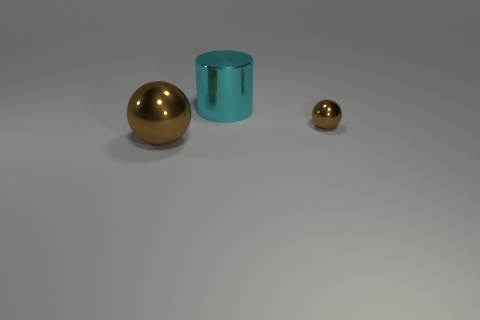Subtract all yellow cylinders. Subtract all yellow balls. How many cylinders are left? 1 Add 1 brown metallic objects. How many objects exist? 4 Subtract all cylinders. How many objects are left? 2 Add 1 metal cylinders. How many metal cylinders exist? 2 Subtract 0 purple spheres. How many objects are left? 3 Subtract all green metallic cylinders. Subtract all big metal spheres. How many objects are left? 2 Add 2 brown spheres. How many brown spheres are left? 4 